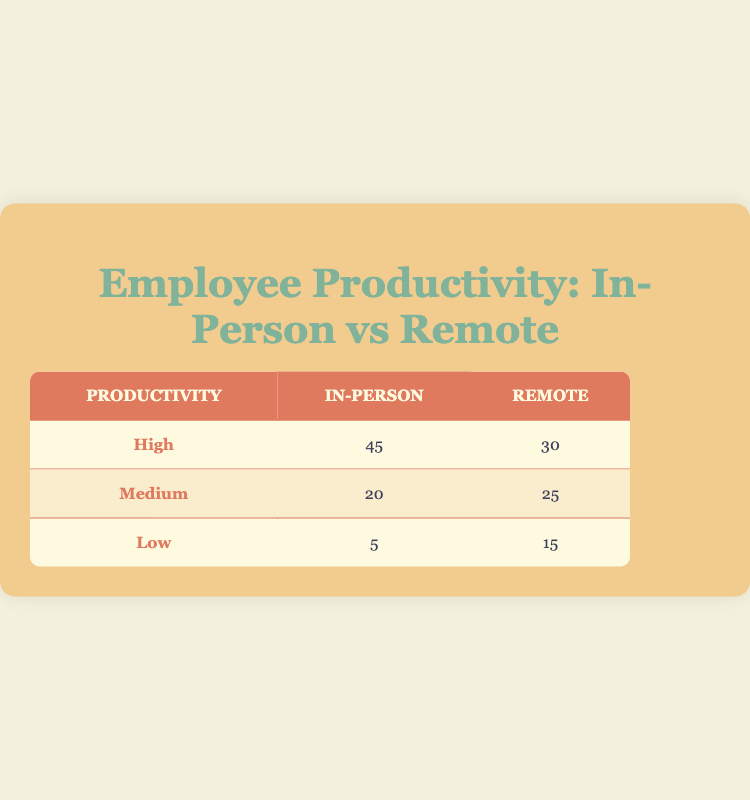What is the total number of employees working in an in-person environment? To find this, we need to sum the counts of all productivity levels for the in-person environment. The counts are 45 for high, 20 for medium, and 5 for low. So, the total is 45 + 20 + 5 = 70.
Answer: 70 How many employees reported low productivity in the remote environment? The count for low productivity in the remote environment is directly given in the table. It states that 15 employees reported low productivity.
Answer: 15 What is the difference in high productivity levels between in-person and remote environments? To find the difference, we subtract the count of high productivity in the remote environment (30) from that in the in-person environment (45). The difference is 45 - 30 = 15.
Answer: 15 What is the average productivity level count for employees working in the in-person environment? To calculate the average, we first sum the productivity counts for in-person: 45 + 20 + 5 = 70. There are 3 productivity categories (high, medium, low), so we divide the total by 3, resulting in 70 / 3 ≈ 23.33.
Answer: 23.33 Is it true that more employees have high productivity in an in-person environment than in a remote environment? From the table, 45 employees are high in in-person, while 30 employees are high in remote. Since 45 is greater than 30, the statement is true.
Answer: Yes How many employees have either medium or low productivity in the remote environment? We sum the counts of medium (25) and low productivity (15) in the remote environment: 25 + 15 = 40.
Answer: 40 How does the total number of employees with high productivity compare to those with low productivity across both environments? The total for high productivity is 45 (in-person) + 30 (remote) = 75. The total for low productivity is 5 (in-person) + 15 (remote) = 20. To compare, we can see that 75 (high) - 20 (low) = 55, indicating that there are significantly more high productivity employees.
Answer: 55 What percentage of remote employees reported medium productivity? For remote employees, the count for medium productivity is 25. First, we find the total number of remote employees: 30 (high) + 25 (medium) + 15 (low) = 70. The percentage is calculated as (25 / 70) * 100 ≈ 35.71%.
Answer: 35.71% Are employee productivity levels higher in the in-person environment compared to the remote environment? To compare, we look at the totals: in-person (45 high + 20 medium + 5 low = 70) versus remote (30 high + 25 medium + 15 low = 70). Both environments have equal totals; thus, the productivity levels are not higher in one over the other.
Answer: No 